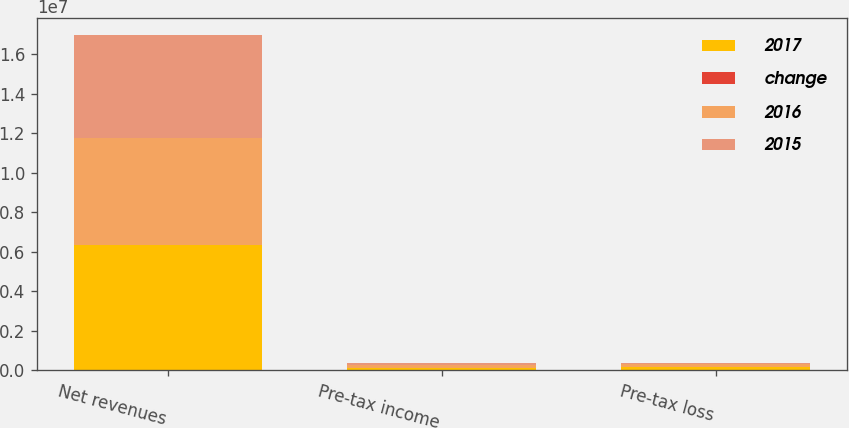<chart> <loc_0><loc_0><loc_500><loc_500><stacked_bar_chart><ecel><fcel>Net revenues<fcel>Pre-tax income<fcel>Pre-tax loss<nl><fcel>2017<fcel>6.3711e+06<fcel>141236<fcel>169879<nl><fcel>change<fcel>18<fcel>1<fcel>14<nl><fcel>2016<fcel>5.40506e+06<fcel>139173<fcel>148548<nl><fcel>2015<fcel>5.20361e+06<fcel>107009<fcel>64849<nl></chart> 